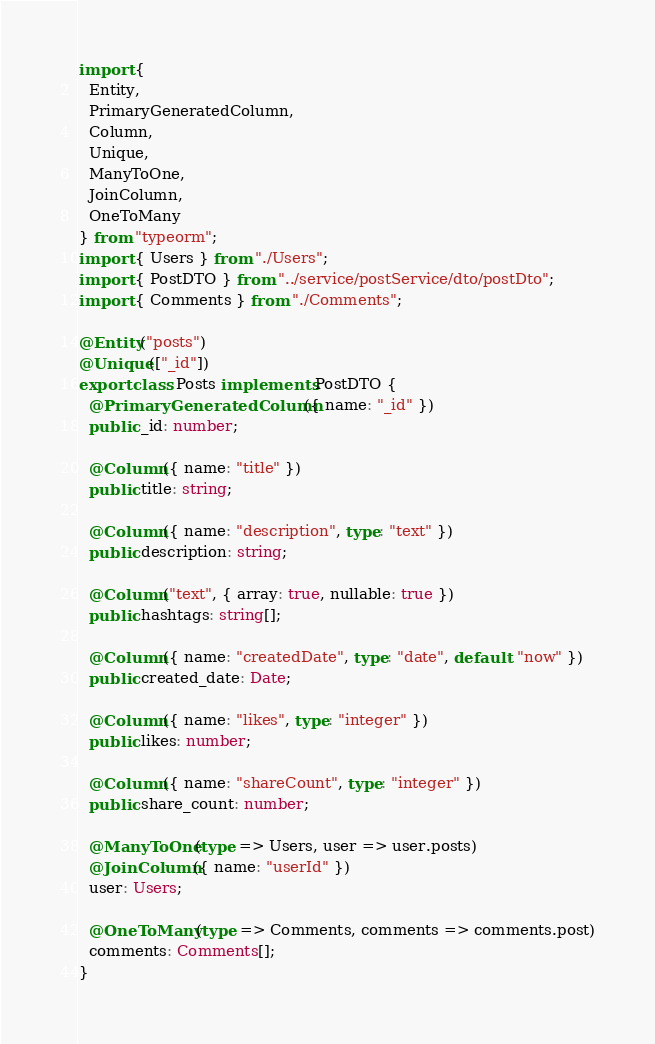<code> <loc_0><loc_0><loc_500><loc_500><_TypeScript_>import {
  Entity,
  PrimaryGeneratedColumn,
  Column,
  Unique,
  ManyToOne,
  JoinColumn,
  OneToMany
} from "typeorm";
import { Users } from "./Users";
import { PostDTO } from "../service/postService/dto/postDto";
import { Comments } from "./Comments";

@Entity("posts")
@Unique(["_id"])
export class Posts implements PostDTO {
  @PrimaryGeneratedColumn({ name: "_id" })
  public _id: number;

  @Column({ name: "title" })
  public title: string;

  @Column({ name: "description", type: "text" })
  public description: string;

  @Column("text", { array: true, nullable: true })
  public hashtags: string[];

  @Column({ name: "createdDate", type: "date", default: "now" })
  public created_date: Date;

  @Column({ name: "likes", type: "integer" })
  public likes: number;

  @Column({ name: "shareCount", type: "integer" })
  public share_count: number;

  @ManyToOne(type => Users, user => user.posts)
  @JoinColumn({ name: "userId" })
  user: Users;

  @OneToMany(type => Comments, comments => comments.post)
  comments: Comments[];
}
</code> 